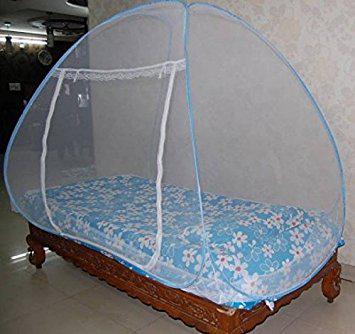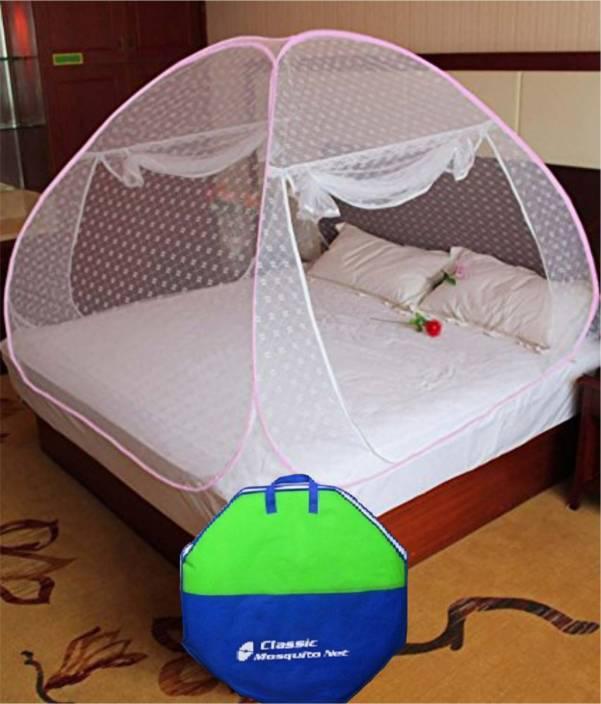The first image is the image on the left, the second image is the image on the right. Examine the images to the left and right. Is the description "there are two brown pillows in the image on the left" accurate? Answer yes or no. No. The first image is the image on the left, the second image is the image on the right. For the images shown, is this caption "In at least one image, a green and blue case sits in front of a bed canopy." true? Answer yes or no. Yes. 